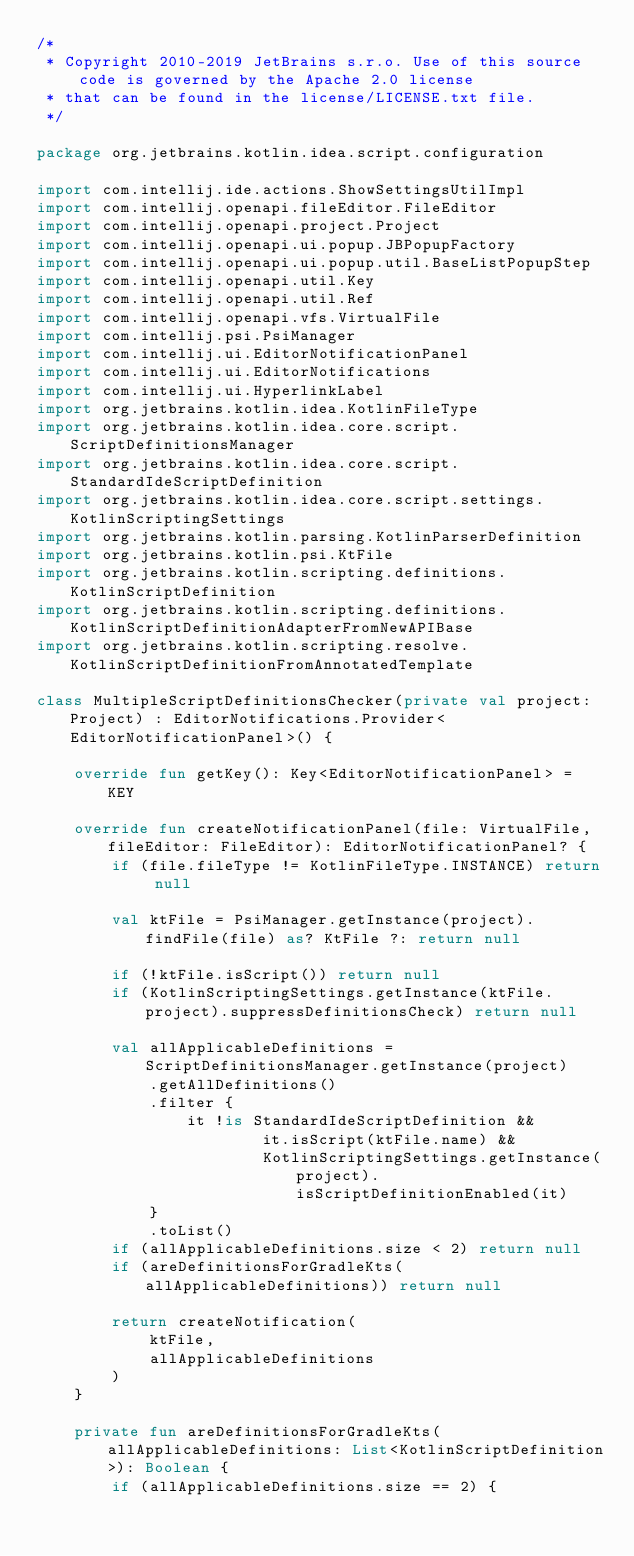Convert code to text. <code><loc_0><loc_0><loc_500><loc_500><_Kotlin_>/*
 * Copyright 2010-2019 JetBrains s.r.o. Use of this source code is governed by the Apache 2.0 license
 * that can be found in the license/LICENSE.txt file.
 */

package org.jetbrains.kotlin.idea.script.configuration

import com.intellij.ide.actions.ShowSettingsUtilImpl
import com.intellij.openapi.fileEditor.FileEditor
import com.intellij.openapi.project.Project
import com.intellij.openapi.ui.popup.JBPopupFactory
import com.intellij.openapi.ui.popup.util.BaseListPopupStep
import com.intellij.openapi.util.Key
import com.intellij.openapi.util.Ref
import com.intellij.openapi.vfs.VirtualFile
import com.intellij.psi.PsiManager
import com.intellij.ui.EditorNotificationPanel
import com.intellij.ui.EditorNotifications
import com.intellij.ui.HyperlinkLabel
import org.jetbrains.kotlin.idea.KotlinFileType
import org.jetbrains.kotlin.idea.core.script.ScriptDefinitionsManager
import org.jetbrains.kotlin.idea.core.script.StandardIdeScriptDefinition
import org.jetbrains.kotlin.idea.core.script.settings.KotlinScriptingSettings
import org.jetbrains.kotlin.parsing.KotlinParserDefinition
import org.jetbrains.kotlin.psi.KtFile
import org.jetbrains.kotlin.scripting.definitions.KotlinScriptDefinition
import org.jetbrains.kotlin.scripting.definitions.KotlinScriptDefinitionAdapterFromNewAPIBase
import org.jetbrains.kotlin.scripting.resolve.KotlinScriptDefinitionFromAnnotatedTemplate

class MultipleScriptDefinitionsChecker(private val project: Project) : EditorNotifications.Provider<EditorNotificationPanel>() {

    override fun getKey(): Key<EditorNotificationPanel> = KEY

    override fun createNotificationPanel(file: VirtualFile, fileEditor: FileEditor): EditorNotificationPanel? {
        if (file.fileType != KotlinFileType.INSTANCE) return null

        val ktFile = PsiManager.getInstance(project).findFile(file) as? KtFile ?: return null

        if (!ktFile.isScript()) return null
        if (KotlinScriptingSettings.getInstance(ktFile.project).suppressDefinitionsCheck) return null

        val allApplicableDefinitions = ScriptDefinitionsManager.getInstance(project)
            .getAllDefinitions()
            .filter {
                it !is StandardIdeScriptDefinition &&
                        it.isScript(ktFile.name) &&
                        KotlinScriptingSettings.getInstance(project).isScriptDefinitionEnabled(it)
            }
            .toList()
        if (allApplicableDefinitions.size < 2) return null
        if (areDefinitionsForGradleKts(allApplicableDefinitions)) return null

        return createNotification(
            ktFile,
            allApplicableDefinitions
        )
    }

    private fun areDefinitionsForGradleKts(allApplicableDefinitions: List<KotlinScriptDefinition>): Boolean {
        if (allApplicableDefinitions.size == 2) {</code> 